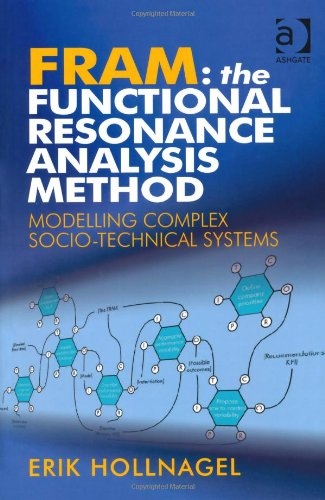What is the title of this book? The book is titled 'FRAM: The Functional Resonance Analysis Method: Modeling Complex Socio-technical Systems', which explores an innovative approach to understanding complex interactions within socio-technical systems. 